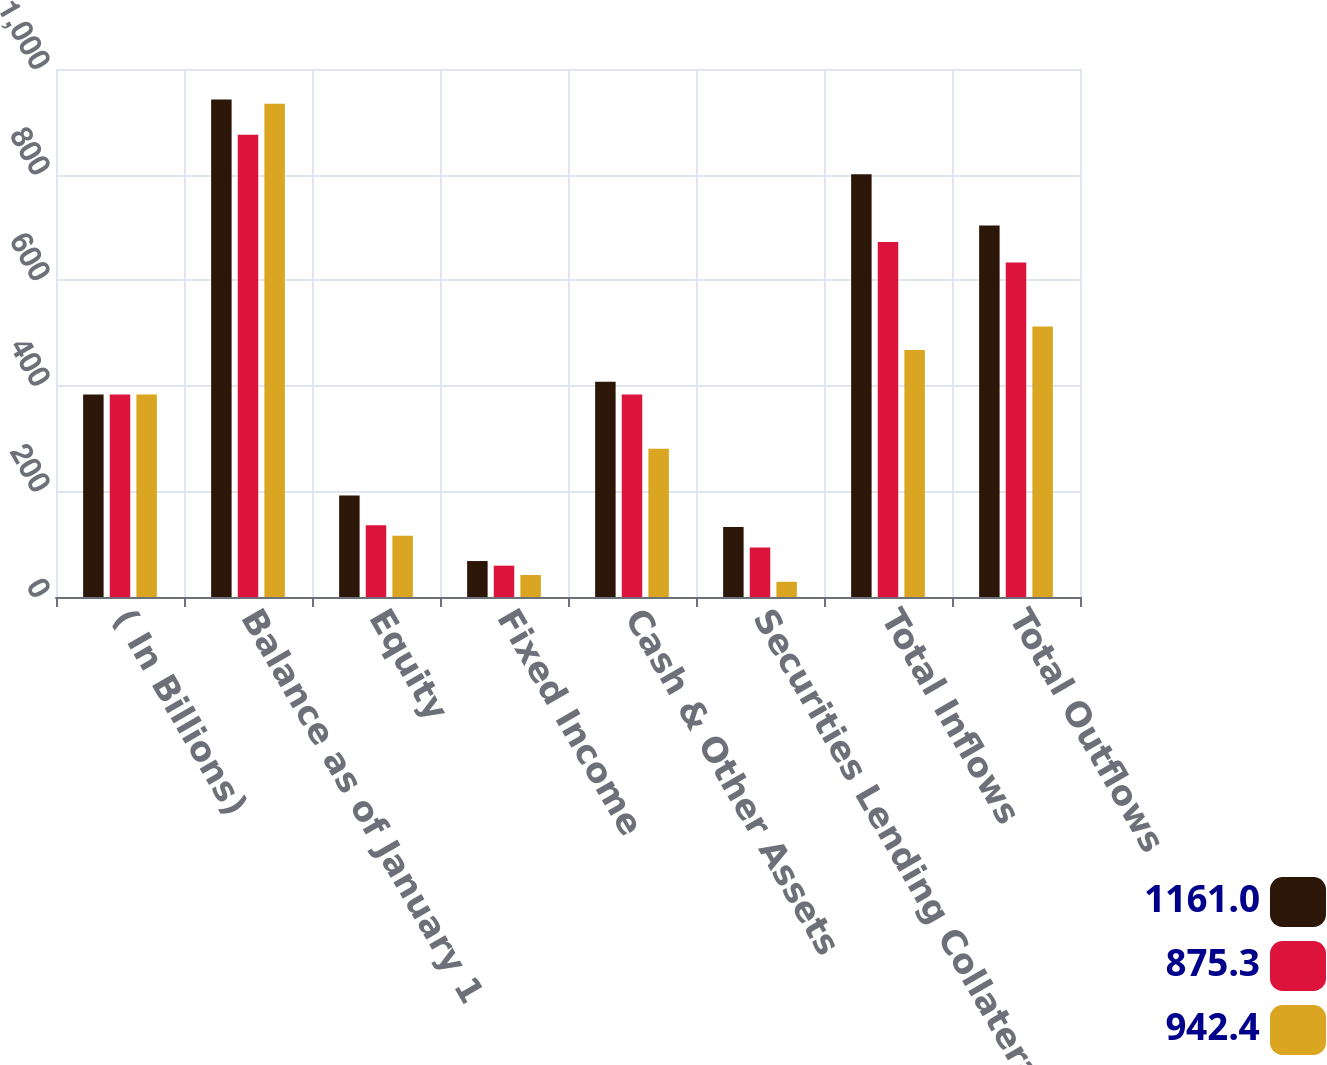Convert chart to OTSL. <chart><loc_0><loc_0><loc_500><loc_500><stacked_bar_chart><ecel><fcel>( In Billions)<fcel>Balance as of January 1<fcel>Equity<fcel>Fixed Income<fcel>Cash & Other Assets<fcel>Securities Lending Collateral<fcel>Total Inflows<fcel>Total Outflows<nl><fcel>1161<fcel>383.4<fcel>942.4<fcel>192.1<fcel>68.1<fcel>407.9<fcel>132.4<fcel>800.5<fcel>703.6<nl><fcel>875.3<fcel>383.4<fcel>875.3<fcel>136<fcel>59.3<fcel>383.4<fcel>93.8<fcel>672.5<fcel>633.4<nl><fcel>942.4<fcel>383.4<fcel>934.1<fcel>116.2<fcel>41.7<fcel>281<fcel>28.8<fcel>467.7<fcel>512.1<nl></chart> 